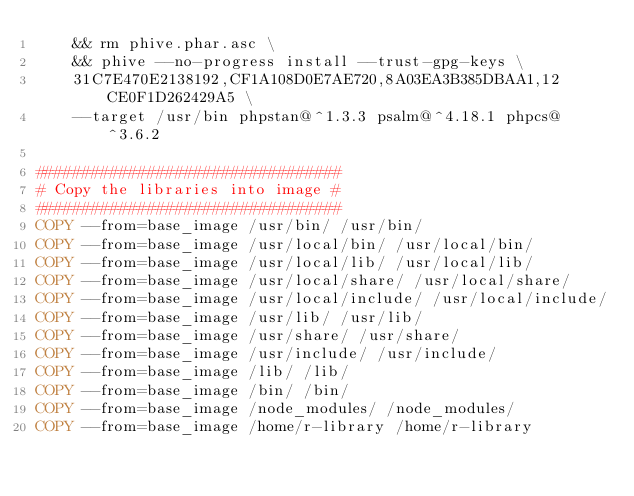<code> <loc_0><loc_0><loc_500><loc_500><_Dockerfile_>    && rm phive.phar.asc \
    && phive --no-progress install --trust-gpg-keys \
    31C7E470E2138192,CF1A108D0E7AE720,8A03EA3B385DBAA1,12CE0F1D262429A5 \
    --target /usr/bin phpstan@^1.3.3 psalm@^4.18.1 phpcs@^3.6.2

#################################
# Copy the libraries into image #
#################################
COPY --from=base_image /usr/bin/ /usr/bin/
COPY --from=base_image /usr/local/bin/ /usr/local/bin/
COPY --from=base_image /usr/local/lib/ /usr/local/lib/
COPY --from=base_image /usr/local/share/ /usr/local/share/
COPY --from=base_image /usr/local/include/ /usr/local/include/
COPY --from=base_image /usr/lib/ /usr/lib/
COPY --from=base_image /usr/share/ /usr/share/
COPY --from=base_image /usr/include/ /usr/include/
COPY --from=base_image /lib/ /lib/
COPY --from=base_image /bin/ /bin/
COPY --from=base_image /node_modules/ /node_modules/
COPY --from=base_image /home/r-library /home/r-library</code> 